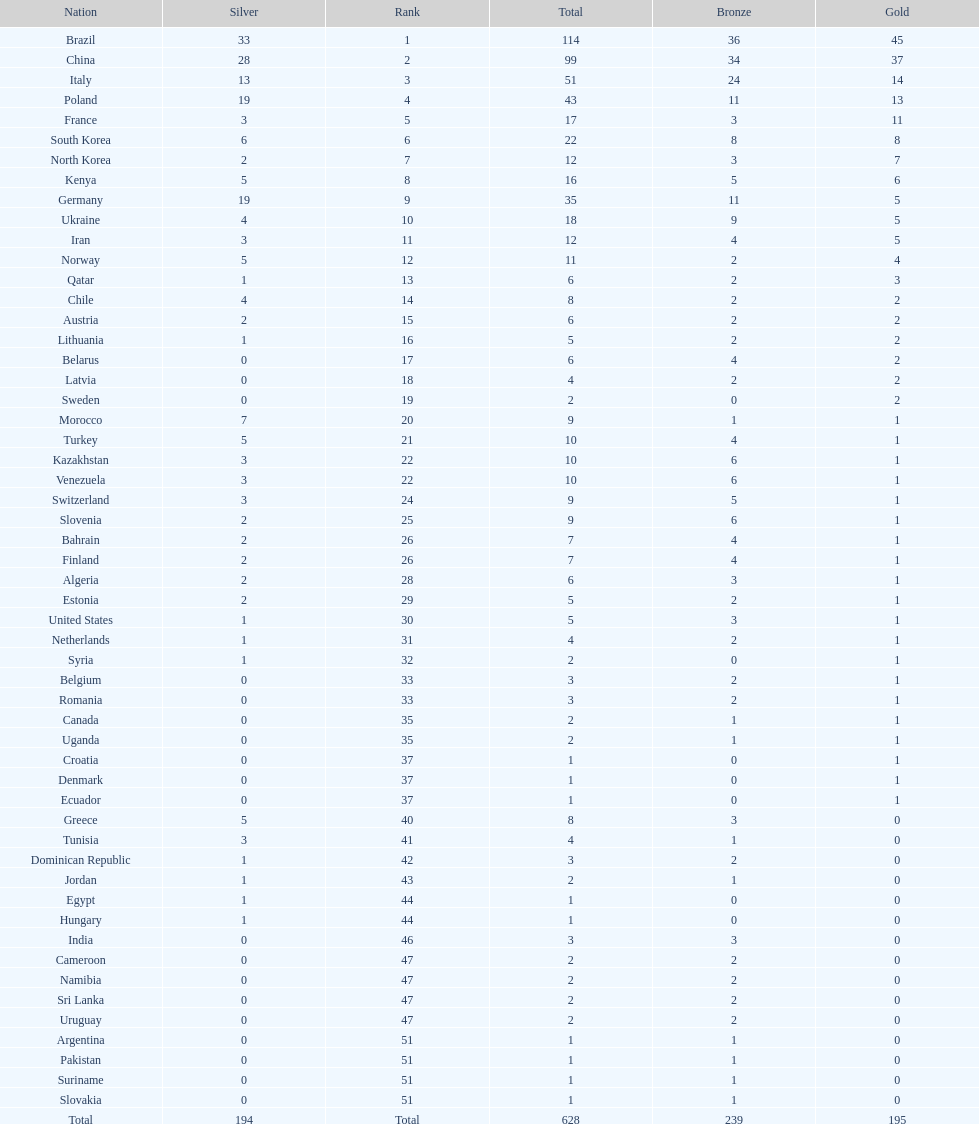Can you parse all the data within this table? {'header': ['Nation', 'Silver', 'Rank', 'Total', 'Bronze', 'Gold'], 'rows': [['Brazil', '33', '1', '114', '36', '45'], ['China', '28', '2', '99', '34', '37'], ['Italy', '13', '3', '51', '24', '14'], ['Poland', '19', '4', '43', '11', '13'], ['France', '3', '5', '17', '3', '11'], ['South Korea', '6', '6', '22', '8', '8'], ['North Korea', '2', '7', '12', '3', '7'], ['Kenya', '5', '8', '16', '5', '6'], ['Germany', '19', '9', '35', '11', '5'], ['Ukraine', '4', '10', '18', '9', '5'], ['Iran', '3', '11', '12', '4', '5'], ['Norway', '5', '12', '11', '2', '4'], ['Qatar', '1', '13', '6', '2', '3'], ['Chile', '4', '14', '8', '2', '2'], ['Austria', '2', '15', '6', '2', '2'], ['Lithuania', '1', '16', '5', '2', '2'], ['Belarus', '0', '17', '6', '4', '2'], ['Latvia', '0', '18', '4', '2', '2'], ['Sweden', '0', '19', '2', '0', '2'], ['Morocco', '7', '20', '9', '1', '1'], ['Turkey', '5', '21', '10', '4', '1'], ['Kazakhstan', '3', '22', '10', '6', '1'], ['Venezuela', '3', '22', '10', '6', '1'], ['Switzerland', '3', '24', '9', '5', '1'], ['Slovenia', '2', '25', '9', '6', '1'], ['Bahrain', '2', '26', '7', '4', '1'], ['Finland', '2', '26', '7', '4', '1'], ['Algeria', '2', '28', '6', '3', '1'], ['Estonia', '2', '29', '5', '2', '1'], ['United States', '1', '30', '5', '3', '1'], ['Netherlands', '1', '31', '4', '2', '1'], ['Syria', '1', '32', '2', '0', '1'], ['Belgium', '0', '33', '3', '2', '1'], ['Romania', '0', '33', '3', '2', '1'], ['Canada', '0', '35', '2', '1', '1'], ['Uganda', '0', '35', '2', '1', '1'], ['Croatia', '0', '37', '1', '0', '1'], ['Denmark', '0', '37', '1', '0', '1'], ['Ecuador', '0', '37', '1', '0', '1'], ['Greece', '5', '40', '8', '3', '0'], ['Tunisia', '3', '41', '4', '1', '0'], ['Dominican Republic', '1', '42', '3', '2', '0'], ['Jordan', '1', '43', '2', '1', '0'], ['Egypt', '1', '44', '1', '0', '0'], ['Hungary', '1', '44', '1', '0', '0'], ['India', '0', '46', '3', '3', '0'], ['Cameroon', '0', '47', '2', '2', '0'], ['Namibia', '0', '47', '2', '2', '0'], ['Sri Lanka', '0', '47', '2', '2', '0'], ['Uruguay', '0', '47', '2', '2', '0'], ['Argentina', '0', '51', '1', '1', '0'], ['Pakistan', '0', '51', '1', '1', '0'], ['Suriname', '0', '51', '1', '1', '0'], ['Slovakia', '0', '51', '1', '1', '0'], ['Total', '194', 'Total', '628', '239', '195']]} How many total medals did norway win? 11. 